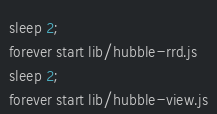Convert code to text. <code><loc_0><loc_0><loc_500><loc_500><_Bash_>sleep 2;
forever start lib/hubble-rrd.js
sleep 2;
forever start lib/hubble-view.js
</code> 